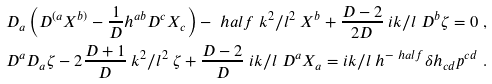<formula> <loc_0><loc_0><loc_500><loc_500>& D _ { a } \left ( D ^ { ( a } X ^ { b ) } - \frac { 1 } { D } h ^ { a b } D ^ { c } X _ { c } \right ) - \ h a l f \ k ^ { 2 } / l ^ { 2 } \ X ^ { b } + \frac { D - 2 } { 2 D } \ i k / l \ D ^ { b } \zeta = 0 \ , \\ & D ^ { a } D _ { a } \zeta - 2 \frac { D + 1 } { D } \ k ^ { 2 } / l ^ { 2 } \ \zeta + \frac { D - 2 } { D } \ i k / l \ D ^ { a } X _ { a } = i k / l \ h ^ { - \ h a l f } \delta h _ { c d } p ^ { c d } \ .</formula> 